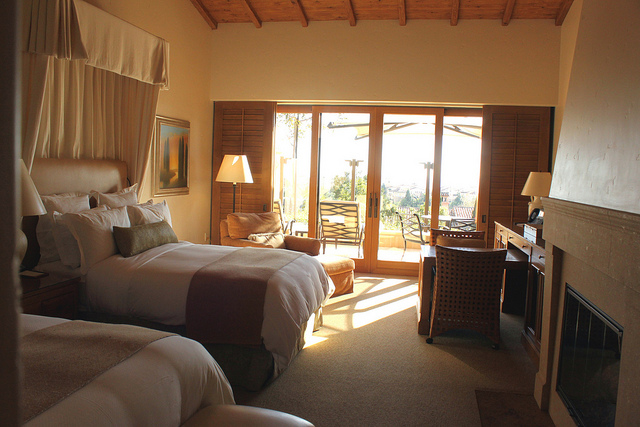<image>What material is the fireplace made of? It is unknown what material the fireplace is made of. It could be wood, cement, brick, stone, or plaster. Is this room on the ground floor? I am not sure whether this room is on the ground floor. It could be on any floor. What material is the fireplace made of? I am not sure what material the fireplace is made of. It can be seen as wood, cement, brick, stone or plaster. Is this room on the ground floor? I don't know if this room is on the ground floor. It can be both on the ground floor or not. 